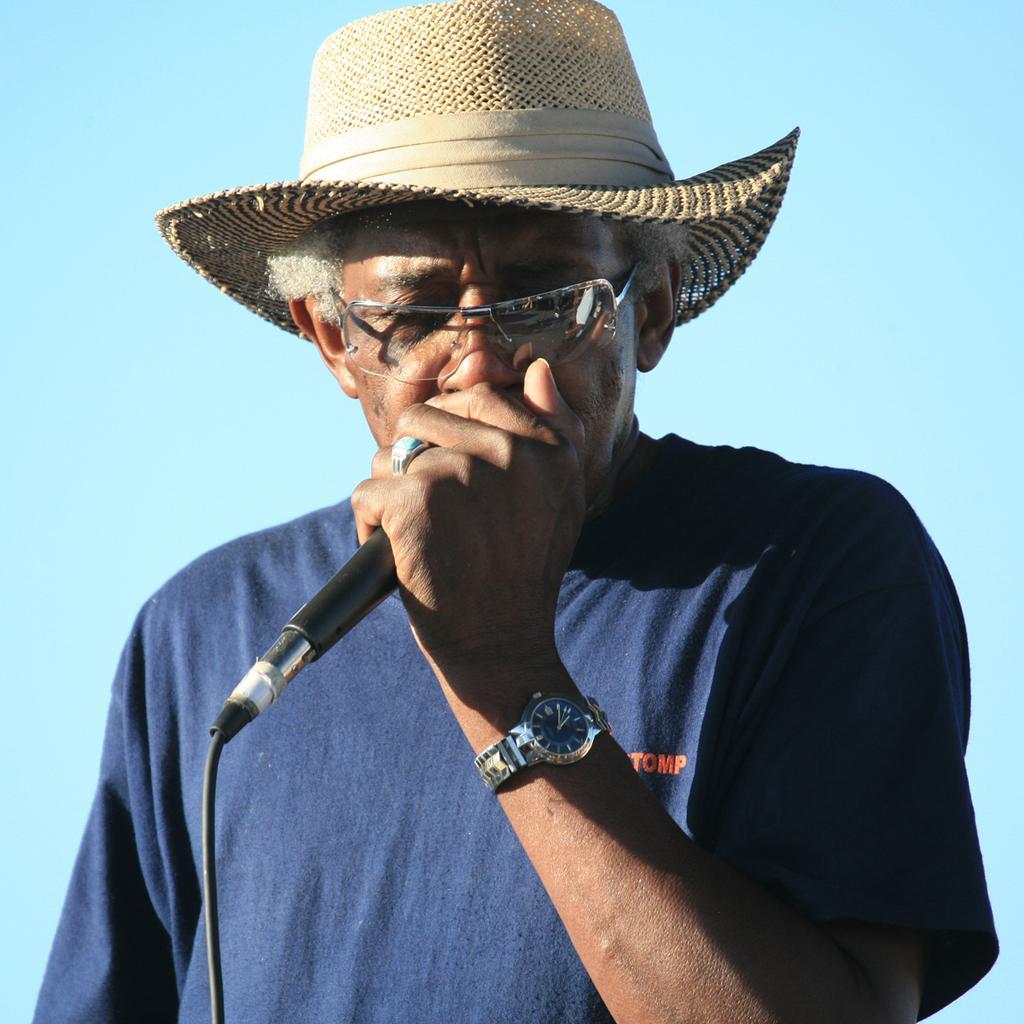Describe this image in one or two sentences. In this picture we can see man wore spectacle, cap, watch holding mic in his hand. 